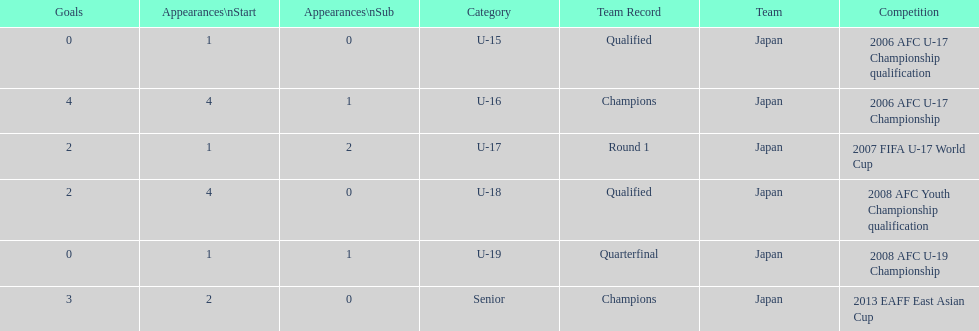In which tournament did japan engage in 2013? 2013 EAFF East Asian Cup. 